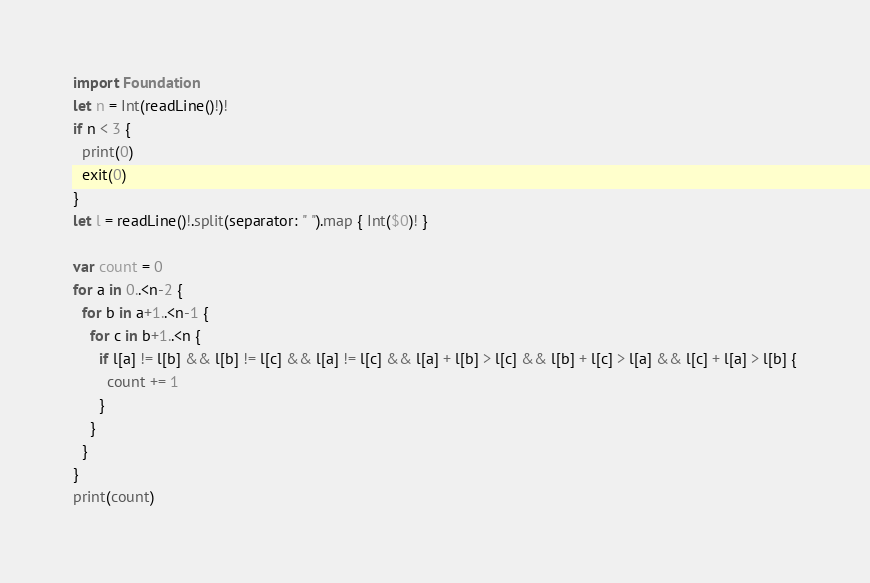Convert code to text. <code><loc_0><loc_0><loc_500><loc_500><_Swift_>import Foundation
let n = Int(readLine()!)!
if n < 3 {
  print(0)
  exit(0)
}
let l = readLine()!.split(separator: " ").map { Int($0)! }

var count = 0
for a in 0..<n-2 {
  for b in a+1..<n-1 {
    for c in b+1..<n {
      if l[a] != l[b] && l[b] != l[c] && l[a] != l[c] && l[a] + l[b] > l[c] && l[b] + l[c] > l[a] && l[c] + l[a] > l[b] {
        count += 1
      }
    }
  }
}
print(count)</code> 